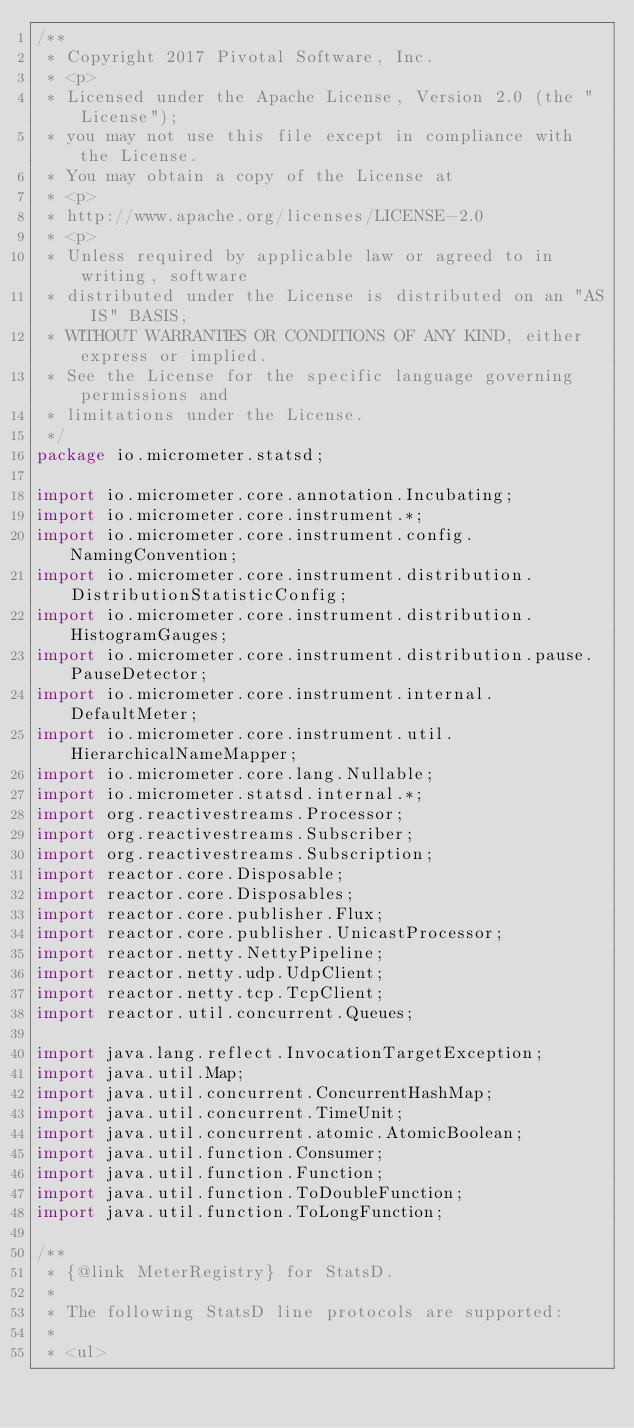Convert code to text. <code><loc_0><loc_0><loc_500><loc_500><_Java_>/**
 * Copyright 2017 Pivotal Software, Inc.
 * <p>
 * Licensed under the Apache License, Version 2.0 (the "License");
 * you may not use this file except in compliance with the License.
 * You may obtain a copy of the License at
 * <p>
 * http://www.apache.org/licenses/LICENSE-2.0
 * <p>
 * Unless required by applicable law or agreed to in writing, software
 * distributed under the License is distributed on an "AS IS" BASIS,
 * WITHOUT WARRANTIES OR CONDITIONS OF ANY KIND, either express or implied.
 * See the License for the specific language governing permissions and
 * limitations under the License.
 */
package io.micrometer.statsd;

import io.micrometer.core.annotation.Incubating;
import io.micrometer.core.instrument.*;
import io.micrometer.core.instrument.config.NamingConvention;
import io.micrometer.core.instrument.distribution.DistributionStatisticConfig;
import io.micrometer.core.instrument.distribution.HistogramGauges;
import io.micrometer.core.instrument.distribution.pause.PauseDetector;
import io.micrometer.core.instrument.internal.DefaultMeter;
import io.micrometer.core.instrument.util.HierarchicalNameMapper;
import io.micrometer.core.lang.Nullable;
import io.micrometer.statsd.internal.*;
import org.reactivestreams.Processor;
import org.reactivestreams.Subscriber;
import org.reactivestreams.Subscription;
import reactor.core.Disposable;
import reactor.core.Disposables;
import reactor.core.publisher.Flux;
import reactor.core.publisher.UnicastProcessor;
import reactor.netty.NettyPipeline;
import reactor.netty.udp.UdpClient;
import reactor.netty.tcp.TcpClient;
import reactor.util.concurrent.Queues;

import java.lang.reflect.InvocationTargetException;
import java.util.Map;
import java.util.concurrent.ConcurrentHashMap;
import java.util.concurrent.TimeUnit;
import java.util.concurrent.atomic.AtomicBoolean;
import java.util.function.Consumer;
import java.util.function.Function;
import java.util.function.ToDoubleFunction;
import java.util.function.ToLongFunction;

/**
 * {@link MeterRegistry} for StatsD.
 *
 * The following StatsD line protocols are supported:
 *
 * <ul></code> 